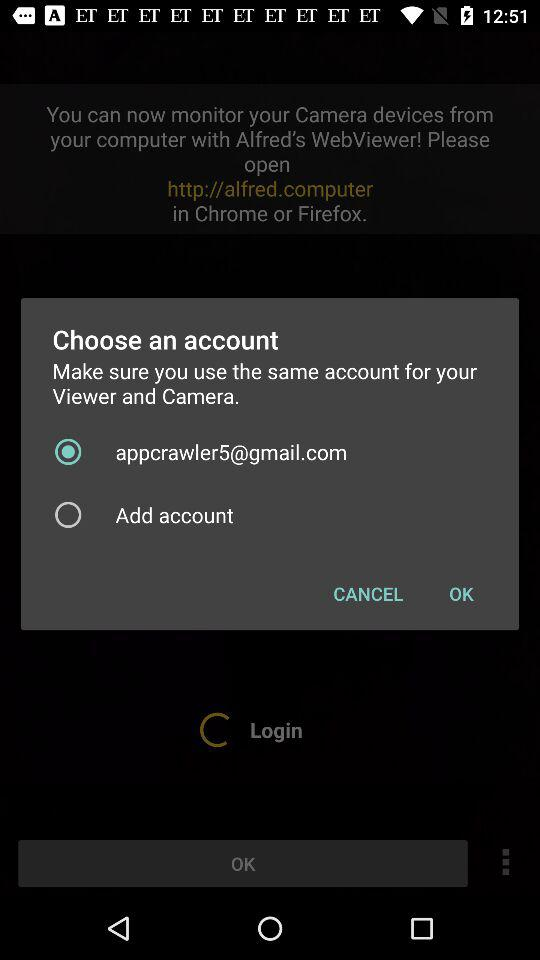How many devices are required to use this app?
Answer the question using a single word or phrase. 2 